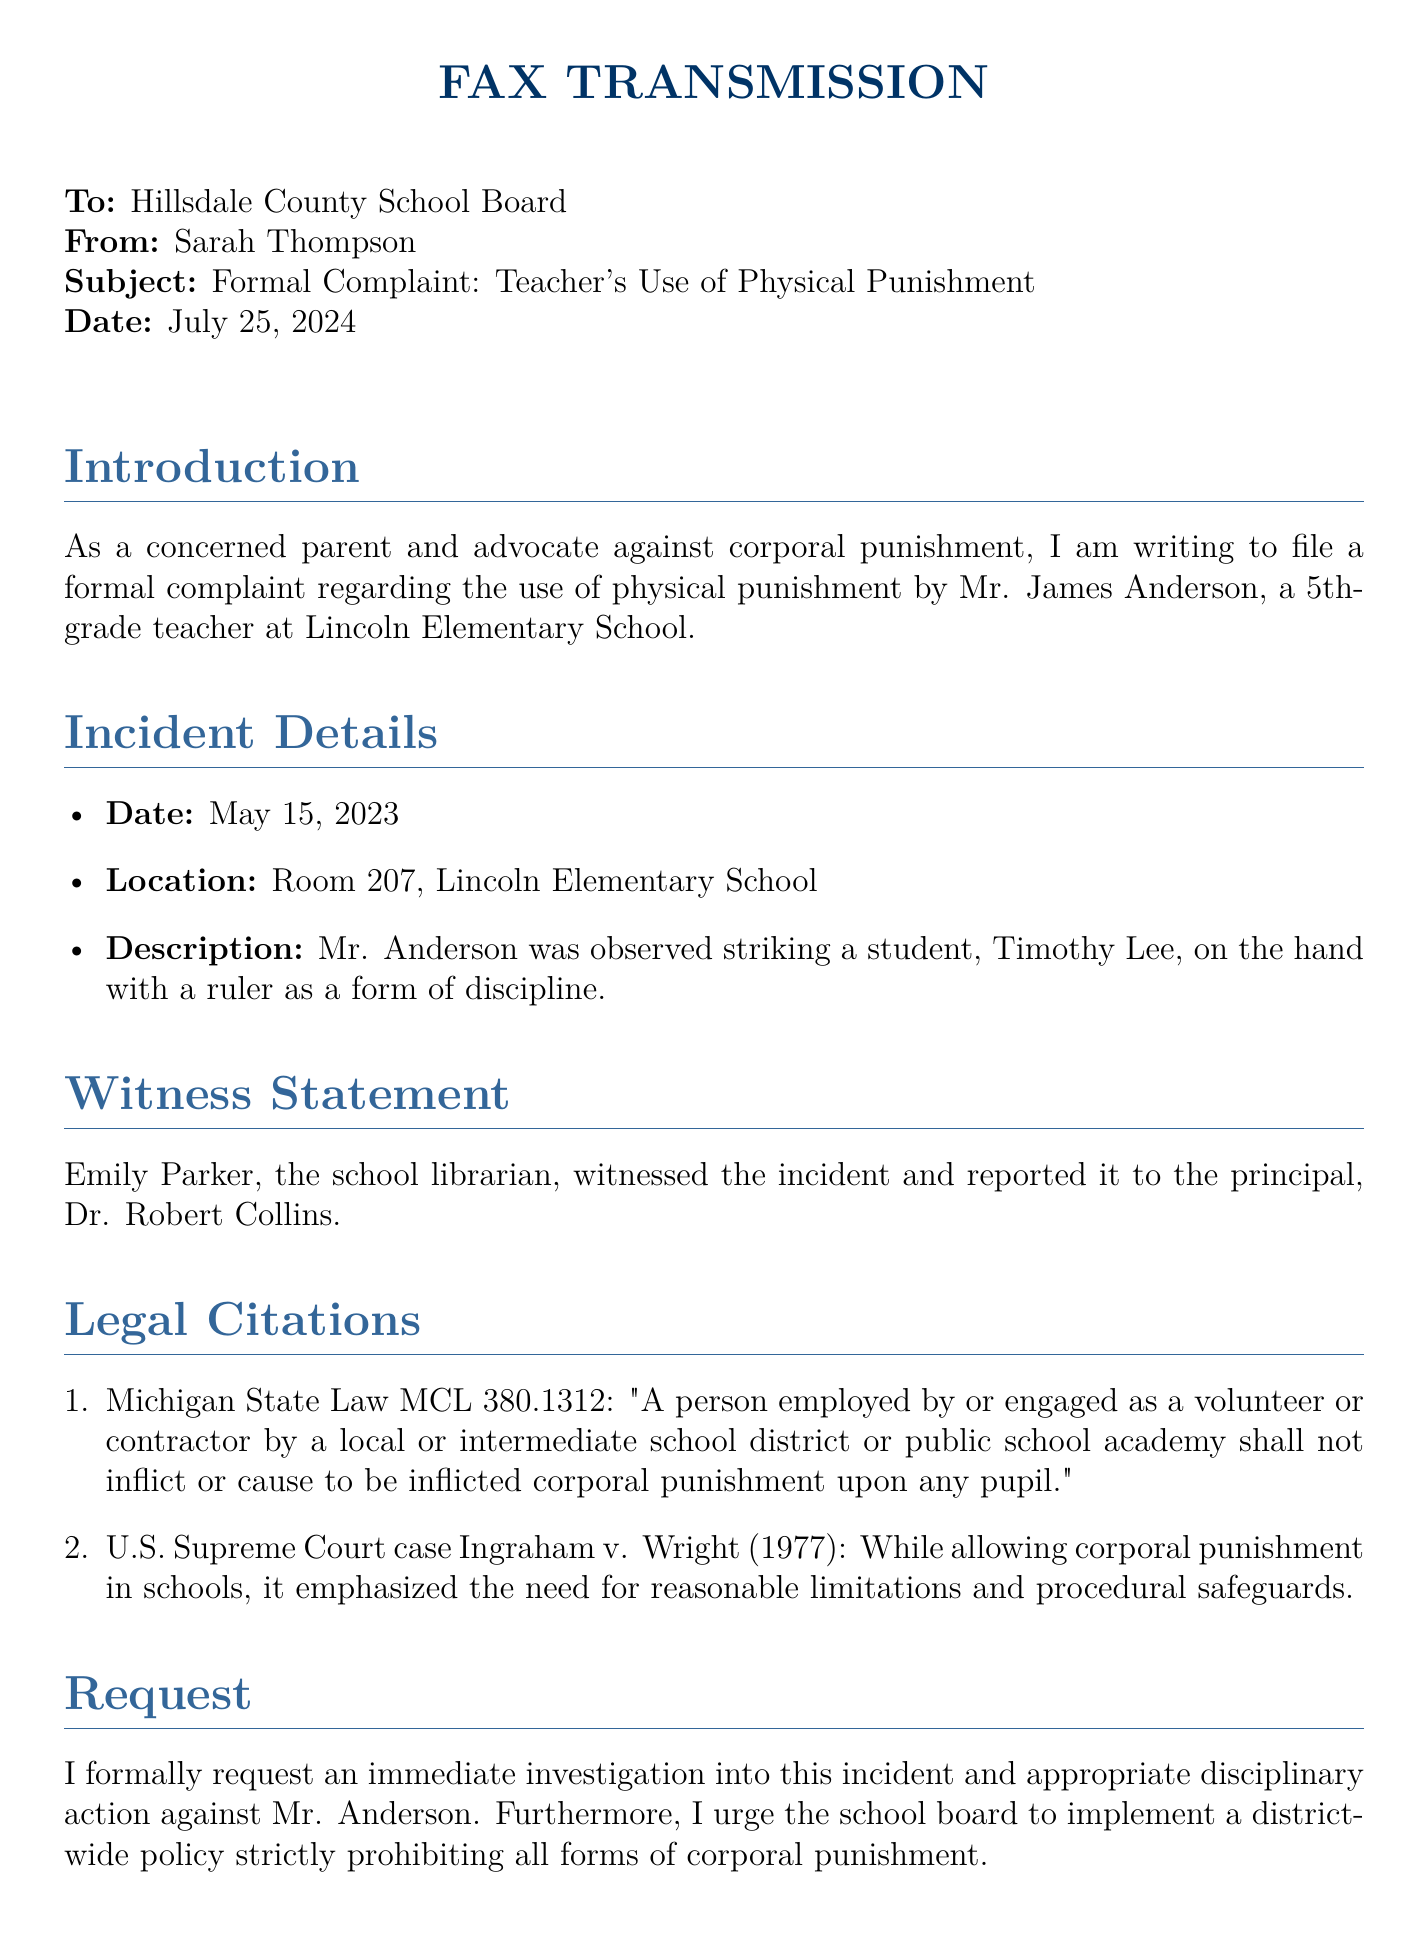what is the date of the incident? The date of the incident is provided in the document.
Answer: May 15, 2023 who is the teacher involved in the incident? The document explicitly names the teacher involved in the incident.
Answer: Mr. James Anderson what punishment was observed? The document describes the specific punishment that took place.
Answer: striking a student on the hand with a ruler who witnessed the incident? The document mentions the individual who witnessed the event.
Answer: Emily Parker what legal citation is referenced regarding corporal punishment? The document cites a specific Michigan state law.
Answer: MCL 380.1312 what is the subject of the fax? The subject line of the fax states the main focus of the complaint.
Answer: Formal Complaint: Teacher's Use of Physical Punishment what is the request made by the sender? The document outlines the main request made by Sarah Thompson.
Answer: immediate investigation and disciplinary action who is the recipient of this fax? The document specifies the intended recipient clearly in the header.
Answer: Hillsdale County School Board 